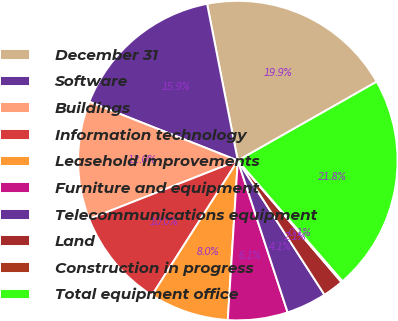Convert chart to OTSL. <chart><loc_0><loc_0><loc_500><loc_500><pie_chart><fcel>December 31<fcel>Software<fcel>Buildings<fcel>Information technology<fcel>Leasehold improvements<fcel>Furniture and equipment<fcel>Telecommunications equipment<fcel>Land<fcel>Construction in progress<fcel>Total equipment office<nl><fcel>19.86%<fcel>15.92%<fcel>11.97%<fcel>10.0%<fcel>8.03%<fcel>6.05%<fcel>4.08%<fcel>2.11%<fcel>0.14%<fcel>21.84%<nl></chart> 